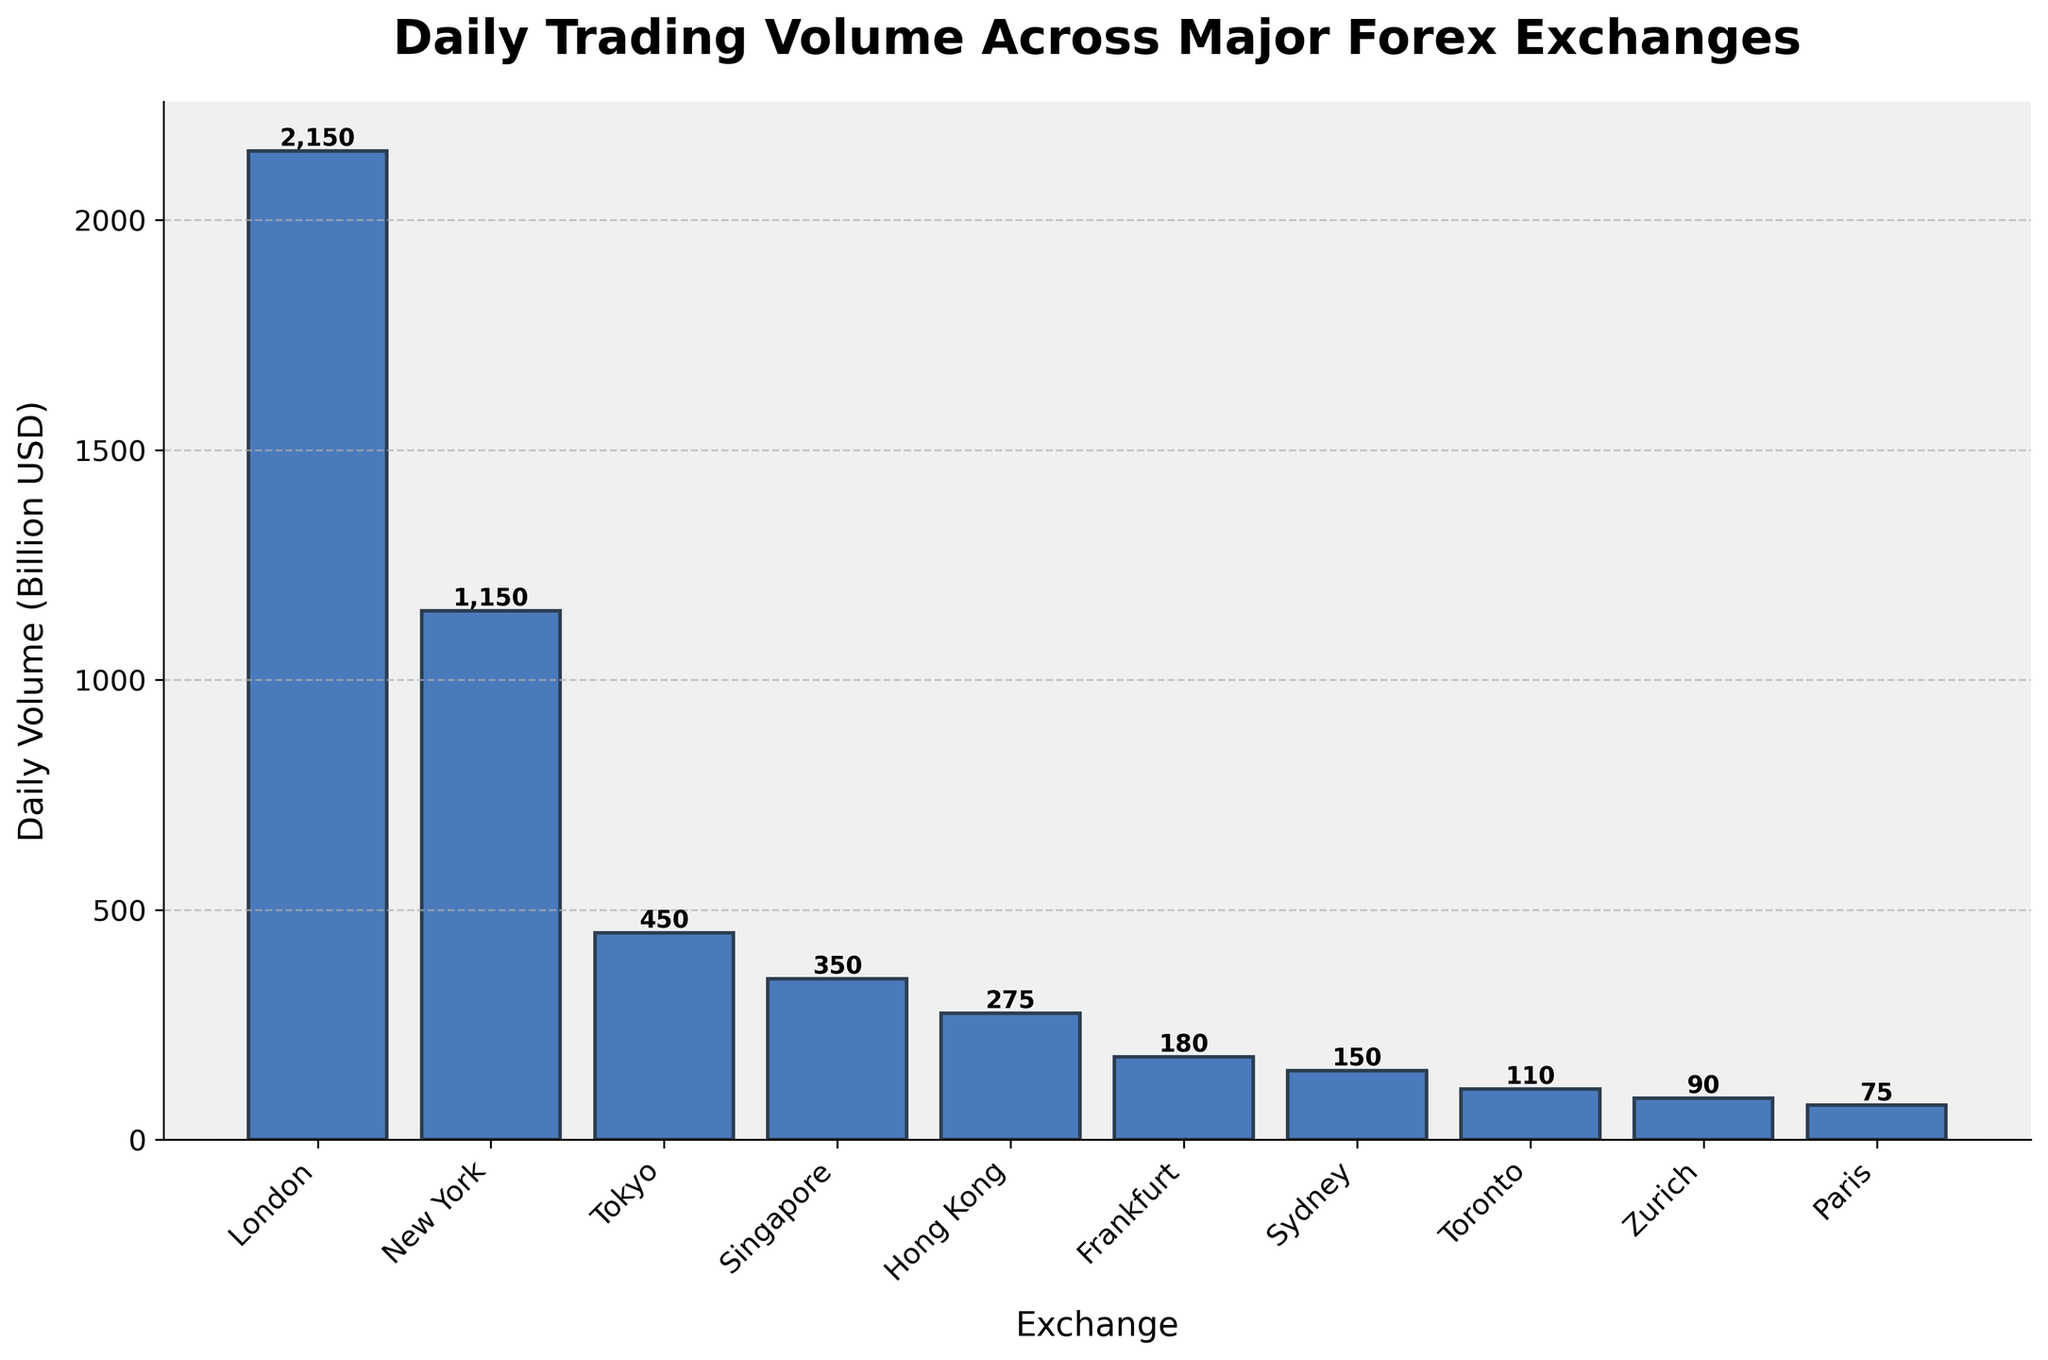What is the title of the plot? The title is displayed at the top of the plot, indicating the primary subject of the bar chart.
Answer: Daily Trading Volume Across Major Forex Exchanges Which exchange has the highest daily trading volume? By visually comparing the heights of the bars, it's evident that the bar representing London is the tallest.
Answer: London How much is the daily trading volume for New York? The height of the bar for New York represents its daily trading volume, and the text above the bar reads 1,150 billion USD.
Answer: 1,150 billion USD What is the total daily trading volume for Tokyo, Singapore, and Hong Kong combined? The volumes for Tokyo (450 B USD), Singapore (350 B USD), and Hong Kong (275 B USD) need to be added together: 450 + 350 + 275 = 1,075.
Answer: 1,075 billion USD How does Frankfurt's daily trading volume compare to Zurich's? By comparing the heights of the bars, Frankfurt has a volume of 180 billion USD and Zurich has 90 billion USD. Frankfurt's trading volume is double that of Zurich's.
Answer: Frankfurt's volume is double Zurich's Which exchange has the lowest daily trading volume? The shortest bar on the plot corresponds to Paris.
Answer: Paris What is the average daily trading volume across all the listed exchanges? Sum the trading volumes of all exchanges and divide by the number of exchanges: (2150 + 1150 + 450 + 350 + 275 + 180 + 150 + 110 + 90 + 75) / 10 = 5980 / 10 = 598.
Answer: 598 billion USD By how much does London's daily trading volume exceed that of New York's? Subtract New York's volume from London's: 2150 - 1150 = 1000.
Answer: 1,000 billion USD What is the difference between the total daily trading volume of the top three and the bottom three exchanges? Sum the top three volumes (London, New York, Tokyo) and the bottom three volumes (Sydney, Toronto, Zurich): (2150 + 1150 + 450) - (110 + 90 + 75) = 3750 - 275 = 3475.
Answer: 3,475 billion USD What percentage of the total daily trading volume does London account for? First, calculate the total volume: 5980 billion USD. Then, divide London's volume by the total and multiply by 100: (2150 / 5980) * 100 ≈ 35.93%.
Answer: 35.93% 